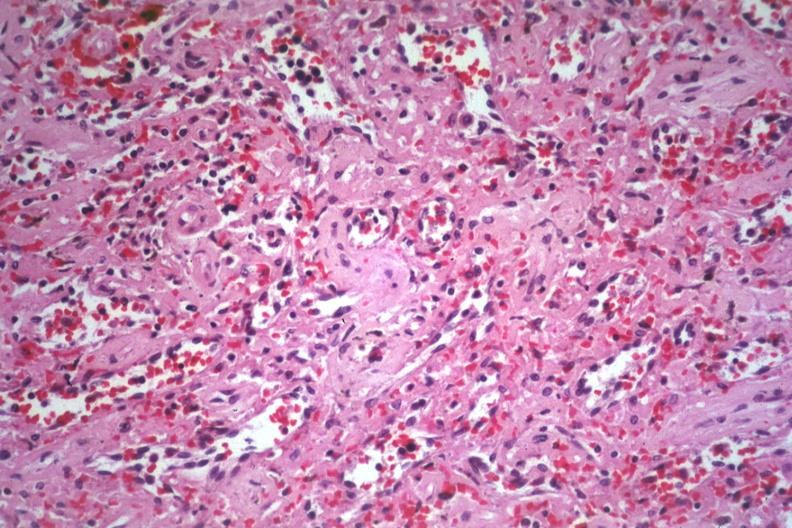s spleen present?
Answer the question using a single word or phrase. Yes 